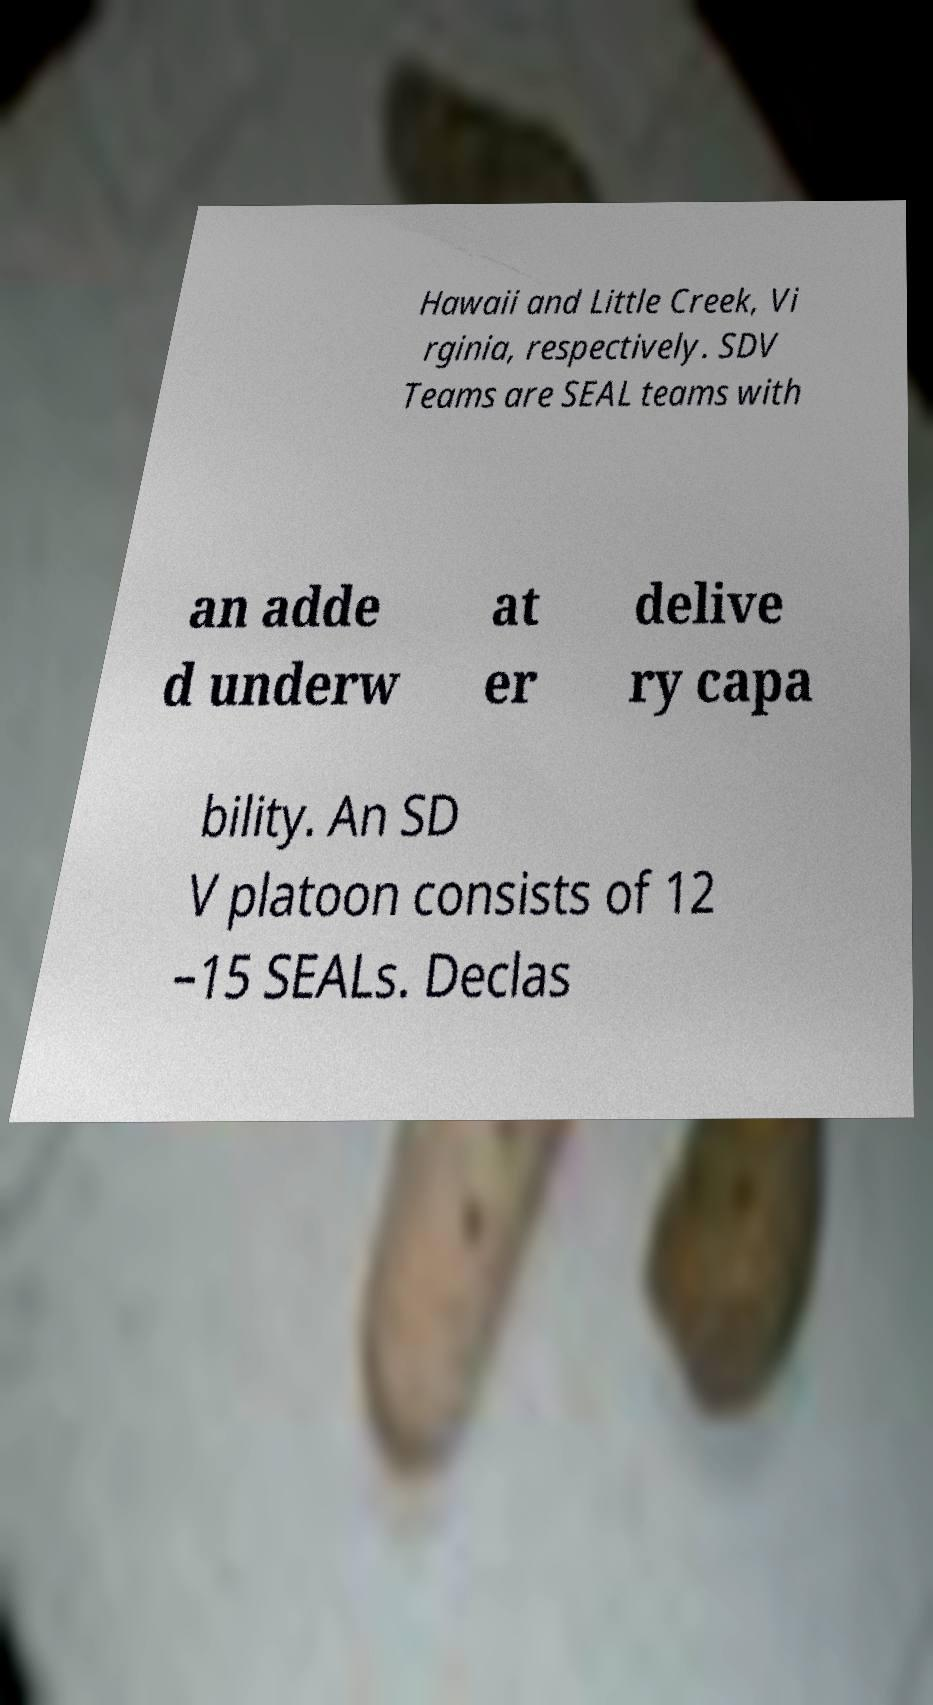I need the written content from this picture converted into text. Can you do that? Hawaii and Little Creek, Vi rginia, respectively. SDV Teams are SEAL teams with an adde d underw at er delive ry capa bility. An SD V platoon consists of 12 –15 SEALs. Declas 